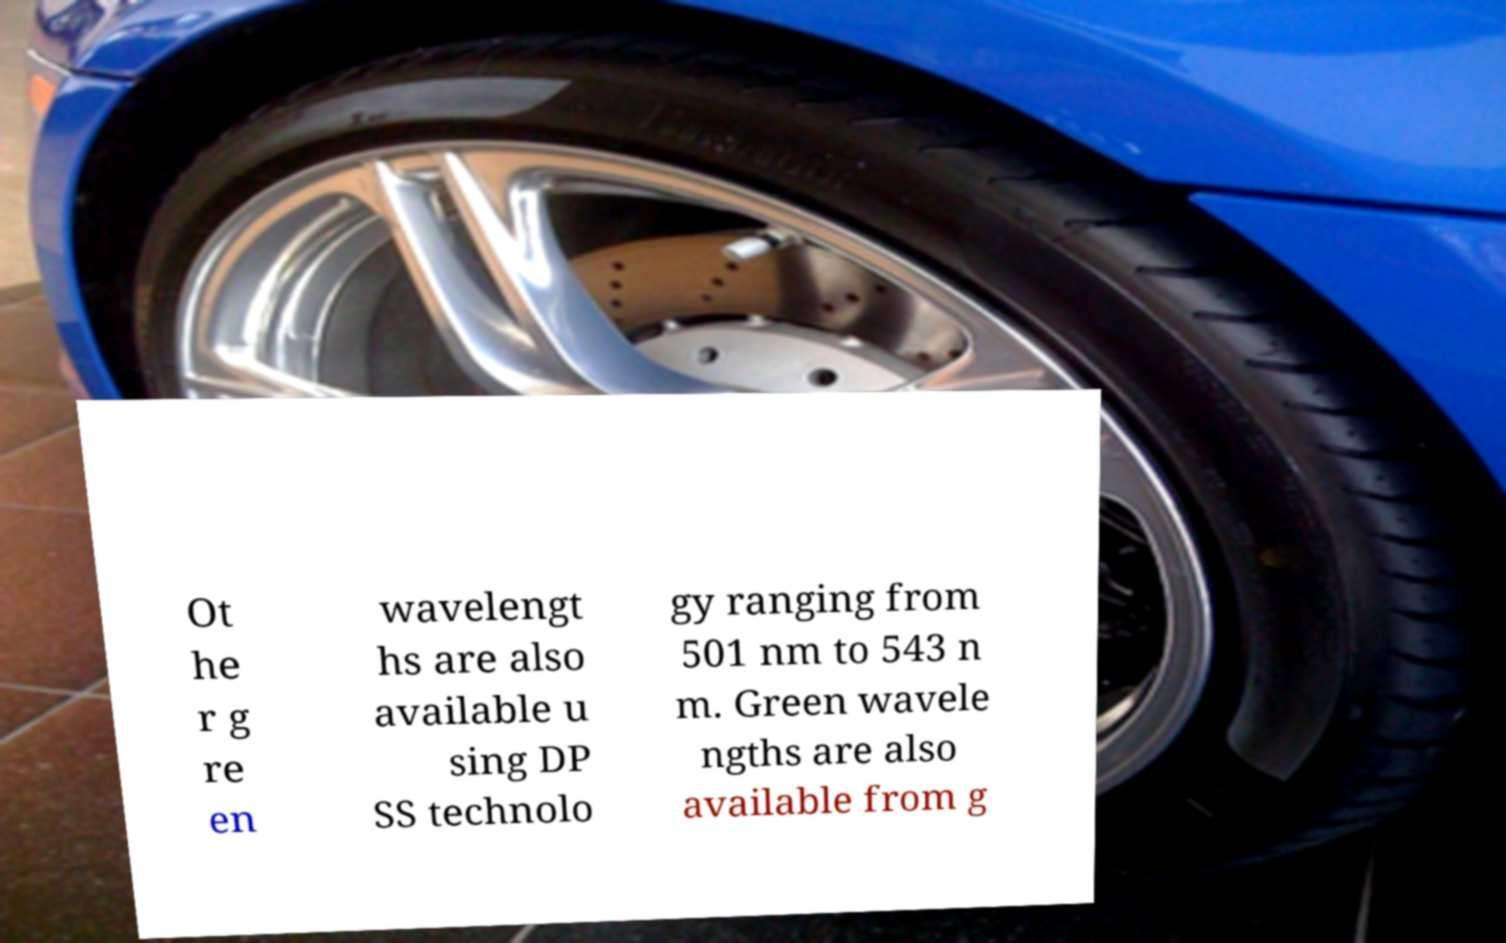Could you assist in decoding the text presented in this image and type it out clearly? Ot he r g re en wavelengt hs are also available u sing DP SS technolo gy ranging from 501 nm to 543 n m. Green wavele ngths are also available from g 